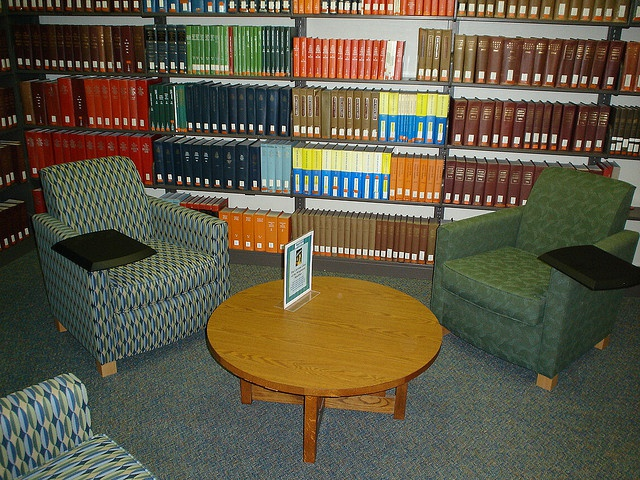Describe the objects in this image and their specific colors. I can see book in darkgreen, black, maroon, gray, and olive tones, chair in darkgreen and black tones, chair in darkgreen, black, gray, olive, and teal tones, couch in darkgreen, black, gray, olive, and teal tones, and couch in darkgreen, gray, darkgray, and blue tones in this image. 